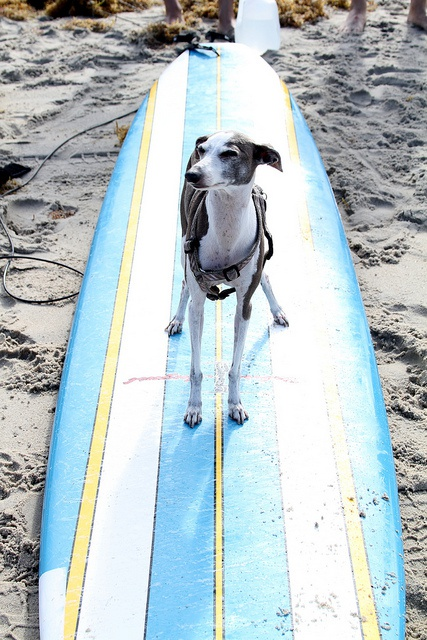Describe the objects in this image and their specific colors. I can see surfboard in tan, white, lightblue, darkgray, and khaki tones and dog in tan, darkgray, lightgray, black, and gray tones in this image. 